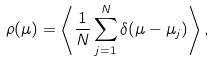<formula> <loc_0><loc_0><loc_500><loc_500>\rho ( \mu ) = \left \langle \frac { 1 } { N } \sum _ { j = 1 } ^ { N } \delta ( \mu - \mu _ { j } ) \right \rangle ,</formula> 